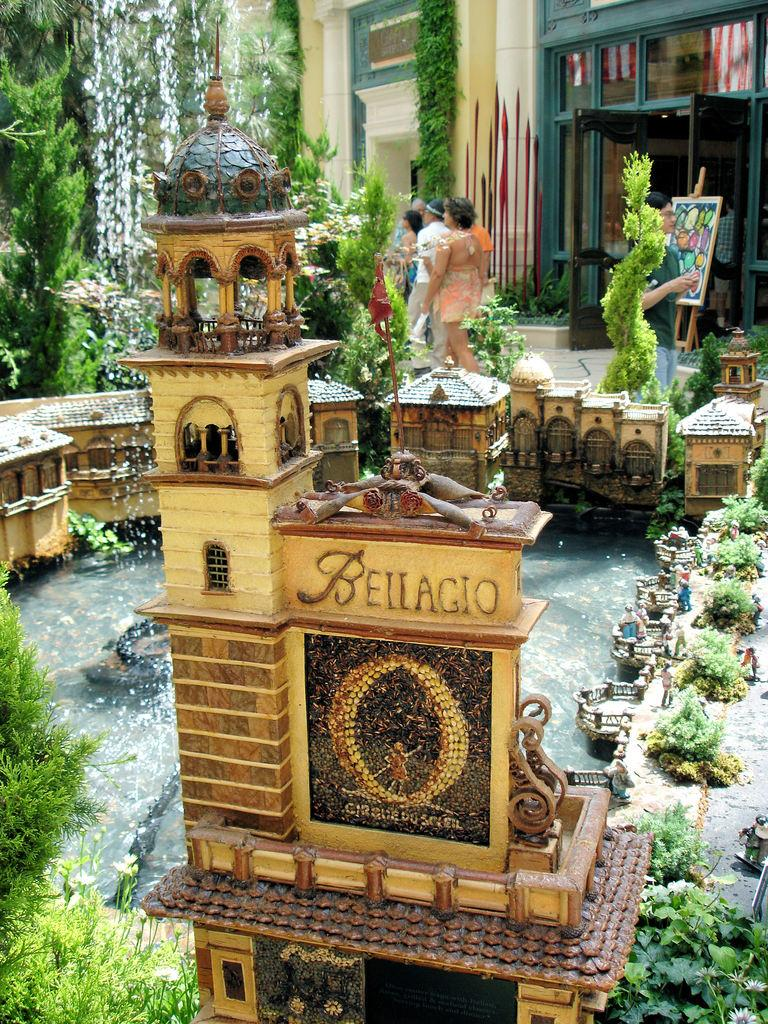What is the main subject of the image? The main subject of the image is a miniature set. What elements are included in the miniature set? The miniature set includes buildings, water, and plants. What can be seen in the background of the image? In the background of the image, there are trees, people, buildings, and a board. How many deer can be seen grazing in the miniature set? There are no deer present in the image; the miniature set includes buildings, water, and plants. What type of stem is used to support the plants in the miniature set? The image does not provide information about the type of stem used to support the plants in the miniature set. 